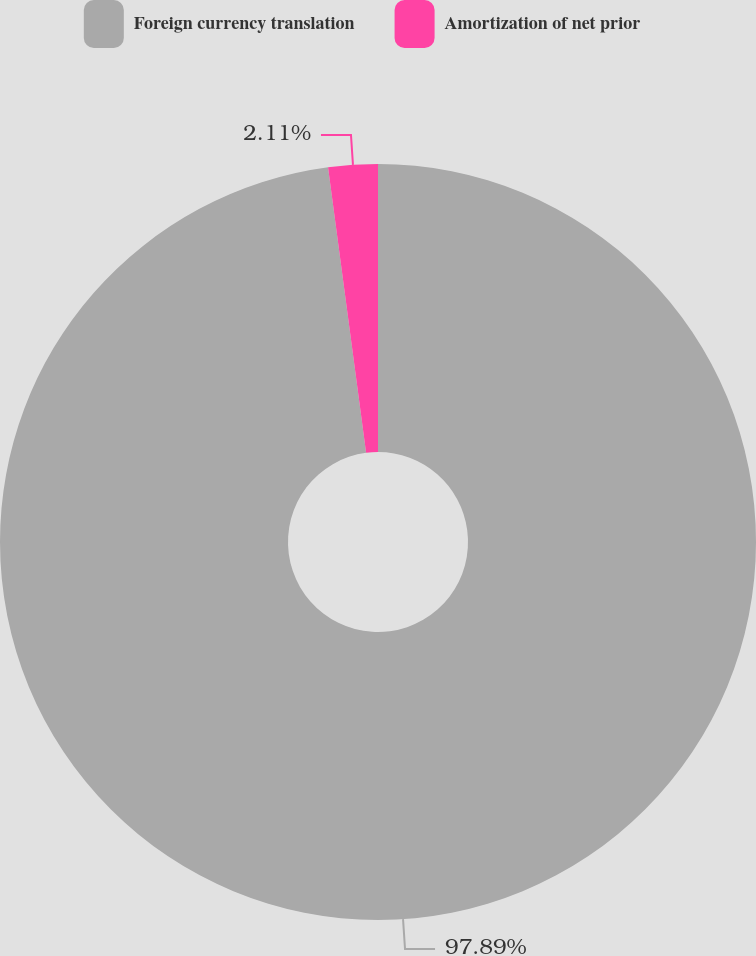Convert chart. <chart><loc_0><loc_0><loc_500><loc_500><pie_chart><fcel>Foreign currency translation<fcel>Amortization of net prior<nl><fcel>97.89%<fcel>2.11%<nl></chart> 